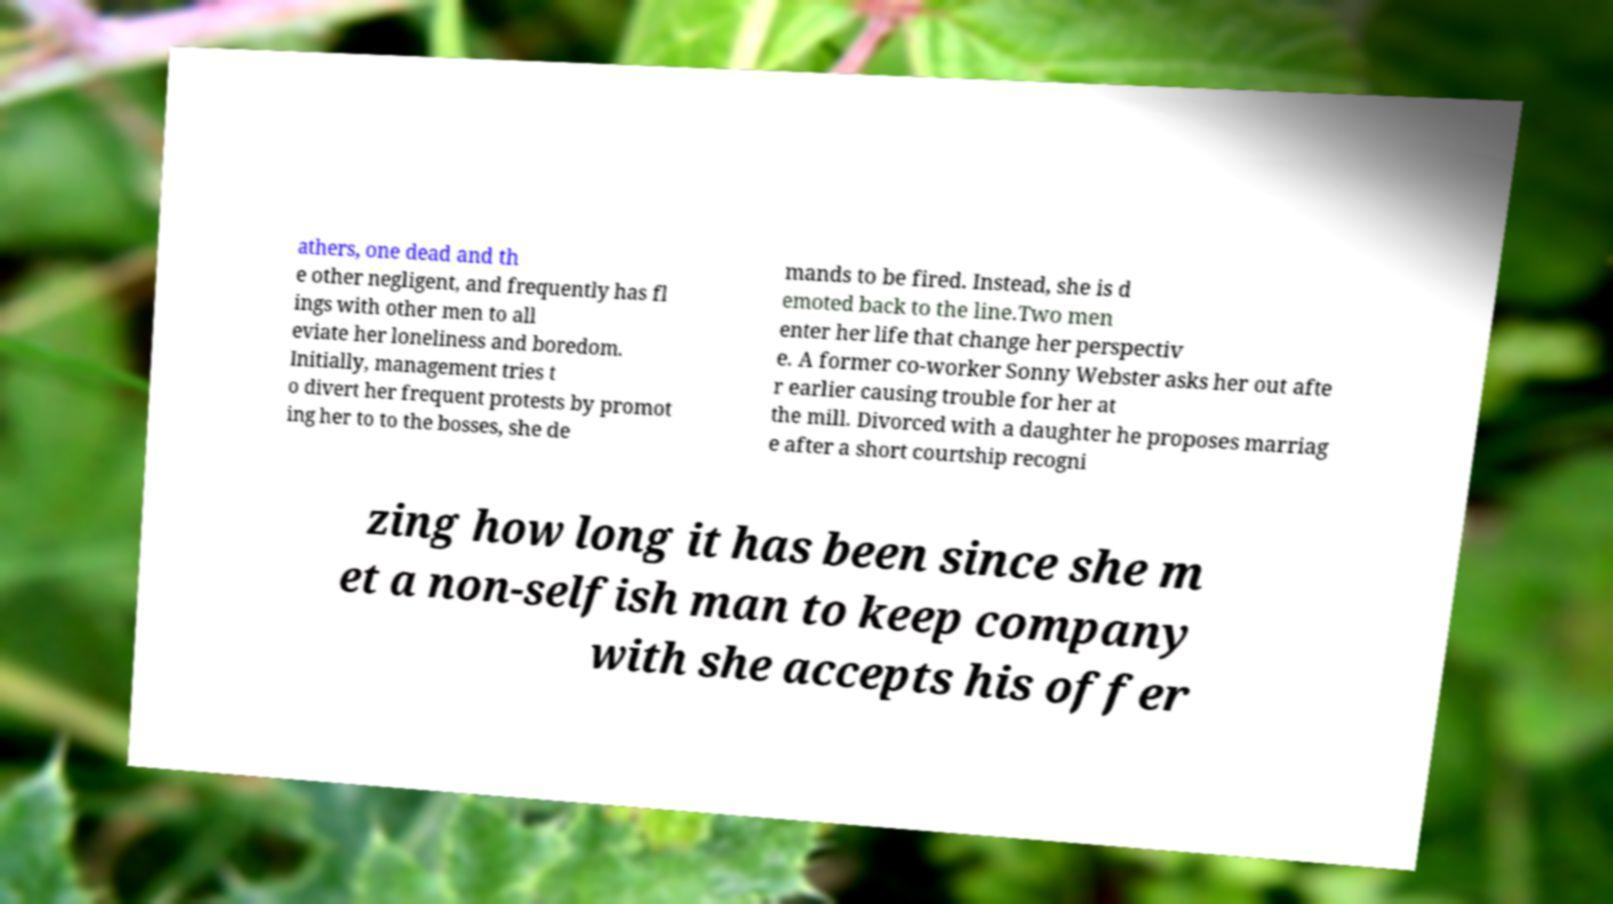Could you extract and type out the text from this image? athers, one dead and th e other negligent, and frequently has fl ings with other men to all eviate her loneliness and boredom. Initially, management tries t o divert her frequent protests by promot ing her to to the bosses, she de mands to be fired. Instead, she is d emoted back to the line.Two men enter her life that change her perspectiv e. A former co-worker Sonny Webster asks her out afte r earlier causing trouble for her at the mill. Divorced with a daughter he proposes marriag e after a short courtship recogni zing how long it has been since she m et a non-selfish man to keep company with she accepts his offer 